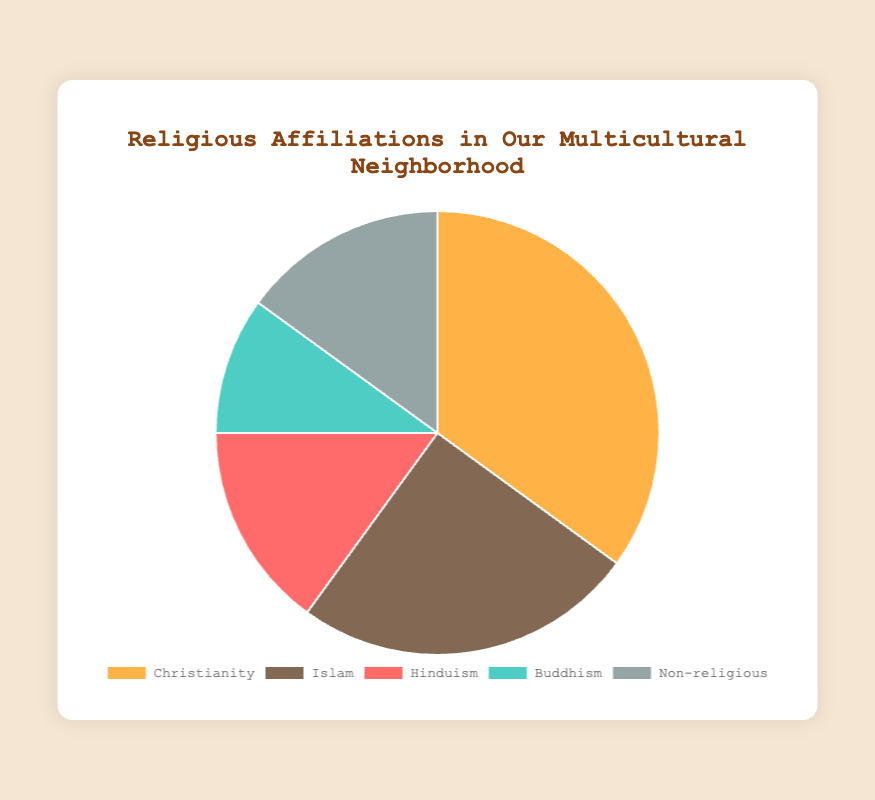Which religion has the largest percentage? By looking at the pie chart, identify the religion with the largest segmented area. Christianity occupies the largest segment with 35%.
Answer: Christianity Which religions have the smallest percentage difference between them? Calculate the percentage difference between the religions by subtracting their percentages, then identify the closest values. Hinduism and Non-religious both have 15%, making the difference 0%.
Answer: Hinduism and Non-religious What is the combined percentage of Islam and Buddhism? Add the percentages of Islam (25%) and Buddhism (10%). This gives you 25 + 10 = 35%.
Answer: 35% How does the percentage of Christianity compare to the sum of Buddhism and Non-religious? Calculate the sum of Buddhism (10%) and Non-religious (15%) which is 10 + 15 = 25%. Compare it to Christianity's 35%. Christianity's 35% is 10% more than the sum.
Answer: Christianity is 10% more Which segment is represented by the color medium turquoise? Match the color medium turquoise to the religion it represents by examining the pie chart. Medium turquoise corresponds to Buddhism.
Answer: Buddhism If you combine the percentages of all non-Christian religions, what is their total percentage? Add the percentages of Islam (25%), Hinduism (15%), Buddhism (10%), and Non-religious (15%). This results in 25 + 15 + 10 + 15 = 65%.
Answer: 65% Which religion's percentage is equal to the average of Christian and Buddhist percentages? Calculate the average of Christian (35%) and Buddhist (10%) percentages: (35 + 10) / 2 = 22.5%. Since no individual percentage is exactly 22.5%, this question trickily shows no direct match.
Answer: No direct match 